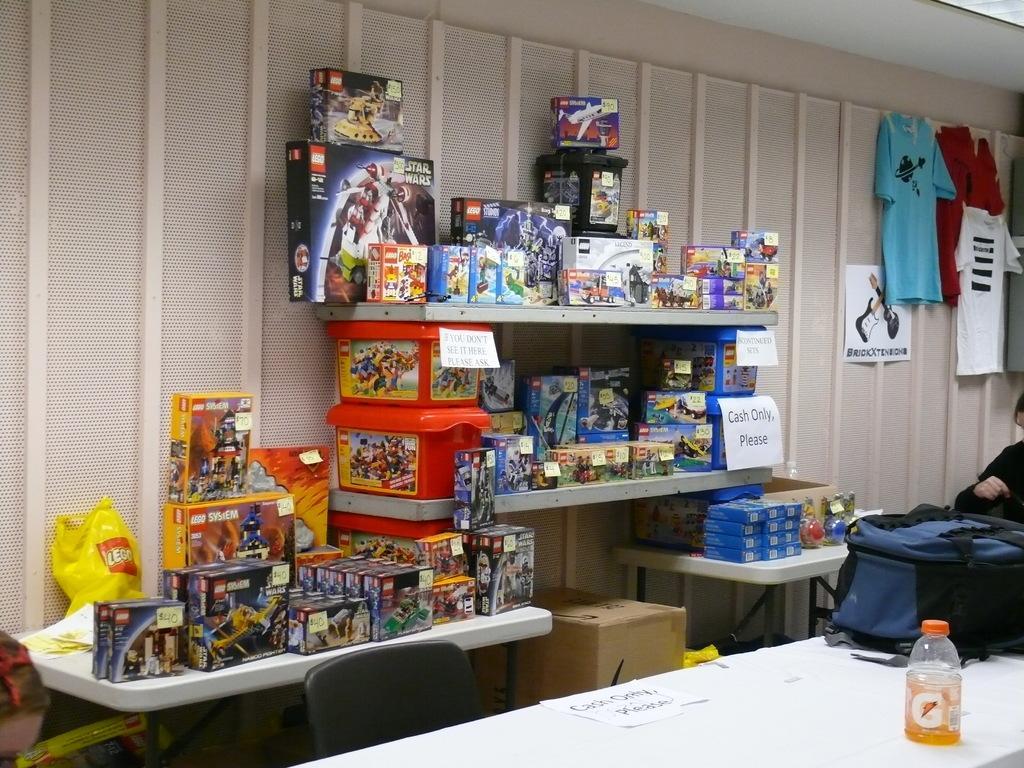Describe this image in one or two sentences. In this picture I can see two persons, there are clothes, papers, boxes of toys, tables, there is a cardboard box, chair, bottle, bag and there are some objects, and in the background there is a wall. 